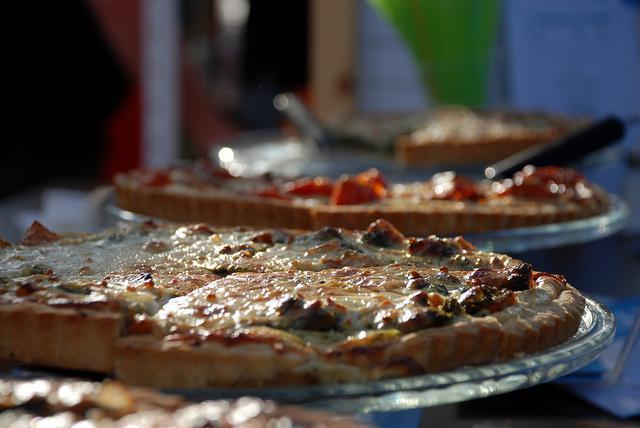How many pizzas are in the photo?
Give a very brief answer. 4. How many red umbrellas are to the right of the woman in the middle?
Give a very brief answer. 0. 